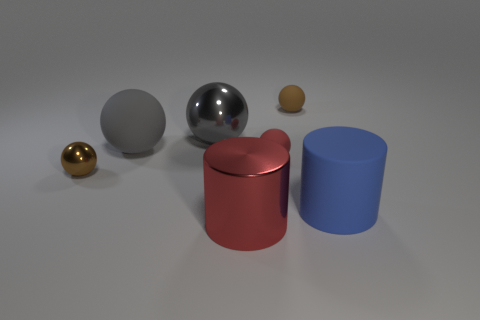The ball that is right of the red cylinder and behind the red rubber object is made of what material?
Your answer should be compact. Rubber. What size is the red cylinder?
Keep it short and to the point. Large. There is a small shiny thing; does it have the same color as the tiny sphere behind the tiny red matte object?
Give a very brief answer. Yes. What number of other things are the same color as the shiny cylinder?
Your answer should be compact. 1. Do the metal object on the left side of the large gray matte object and the rubber sphere that is left of the big red object have the same size?
Your answer should be compact. No. The metal sphere on the left side of the large gray rubber sphere is what color?
Offer a very short reply. Brown. Is the number of matte objects in front of the big blue rubber thing less than the number of cyan things?
Offer a very short reply. No. Do the red cylinder and the large blue cylinder have the same material?
Your response must be concise. No. The red object that is the same shape as the brown matte thing is what size?
Your answer should be compact. Small. What number of things are cylinders behind the red cylinder or objects that are behind the blue cylinder?
Ensure brevity in your answer.  6. 